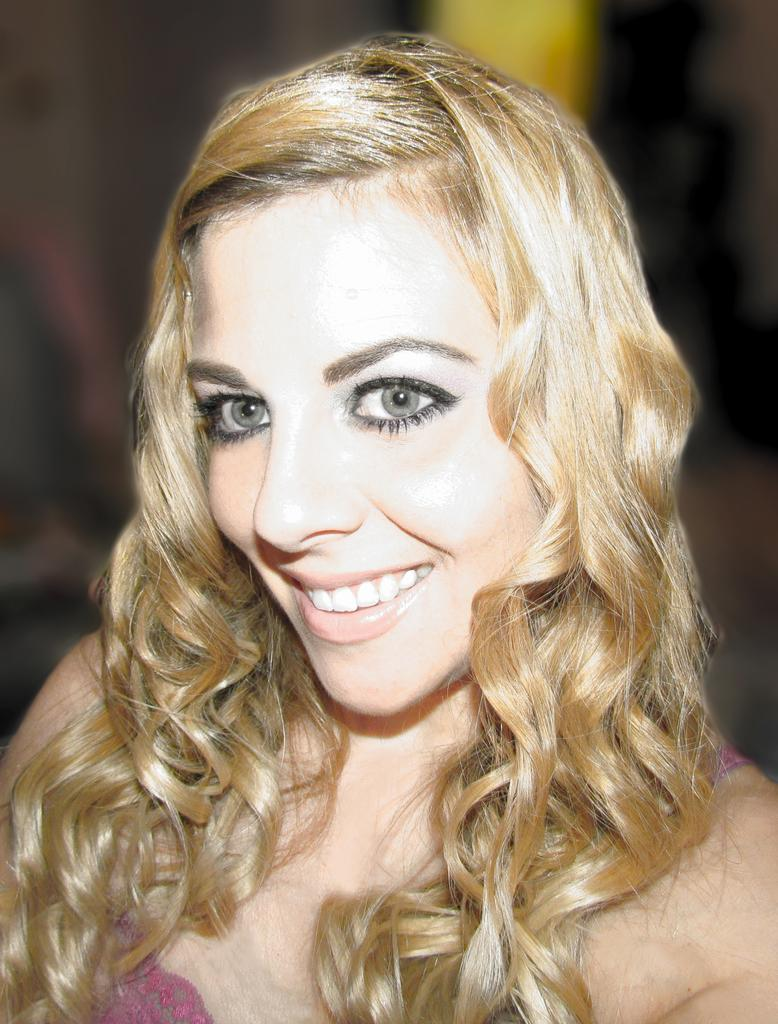Who is the main subject in the image? There is a lady in the center of the image. What is the lady doing in the image? The lady is smiling. Can you describe the background of the image? The background of the image is blurry. How many houses can be seen near the ocean in the image? There is no ocean or houses present in the image. What is the lady's answer to the question she is holding in the image? There is no question or answer visible in the image. 